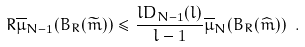Convert formula to latex. <formula><loc_0><loc_0><loc_500><loc_500>R \overline { \mu } _ { N - 1 } ( B _ { R } ( \widetilde { m } ) ) \leq \frac { l D _ { N - 1 } ( l ) } { l - 1 } \overline { \mu } _ { N } ( B _ { R } ( \widehat { m } ) ) \ .</formula> 